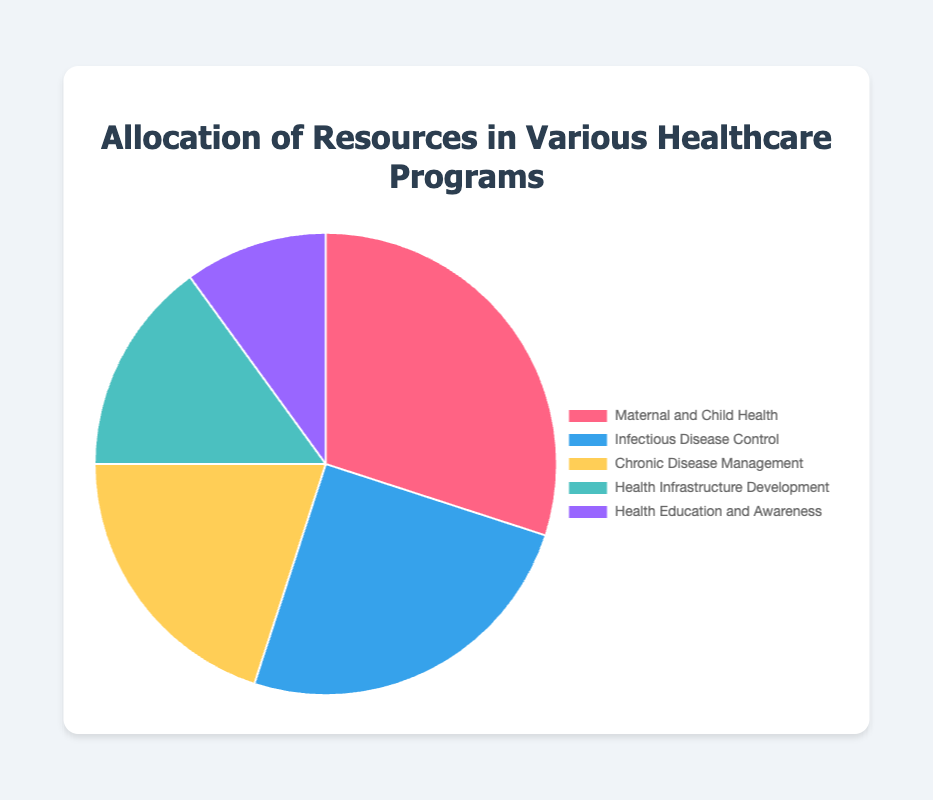What percentage of resources is allocated to Maternal and Child Health? The pie chart shows the percentage allocation of resources to various healthcare programs. From the chart, Maternal and Child Health is allocated 30% of the resources.
Answer: 30% Which program receives the least allocation of resources? By examining the pie chart, the segment for Health Education and Awareness is the smallest, indicating it receives the least allocation at 10%.
Answer: Health Education and Awareness How much more is allocated to Infectious Disease Control than to Health Infrastructure Development? Infectious Disease Control is allocated 25% and Health Infrastructure Development is allocated 15%. The difference between the two allocations is 25% - 15% = 10%.
Answer: 10% Compare the total allocation for Chronic Disease Management and Health Infrastructure Development. Chronic Disease Management is allocated 20% and Health Infrastructure Development 15%. Summing these, 20% + 15% = 35%.
Answer: 35% Which program received a similar allocation to Infectious Disease Control? By looking at the pie chart, the allocation for Chronic Disease Management at 20% is close to the 25% allocated to Infectious Disease Control, but not exactly the same.
Answer: None What proportion of resources is devoted to Health Infrastructure Development compared to the total allocation for Health Education and Awareness and Maternal and Child Health combined? Health Infrastructure Development is allocated 15%. Health Education and Awareness and Maternal and Child Health have a combined allocation of 10% + 30% = 40%. The proportion is 15% / 40% = 0.375.
Answer: 0.375 Identify the program with the second highest allocation and state its percentage. The pie chart shows Maternal and Child Health has the highest allocation at 30%. The next largest segment is Infectious Disease Control with 25% allocation.
Answer: Infectious Disease Control, 25% What is the average allocation percentage across all the healthcare programs mentioned? The total allocation percentages are 30%, 25%, 20%, 15%, and 10%. Adding these gives 100%. Dividing by the number of programs, 100% / 5 = 20%.
Answer: 20% Which segment would be represented by the blue section of the pie chart? According to the color-coding in the pie chart, Infectious Disease Control is represented by the blue section, which has a 25% allocation.
Answer: Infectious Disease Control 